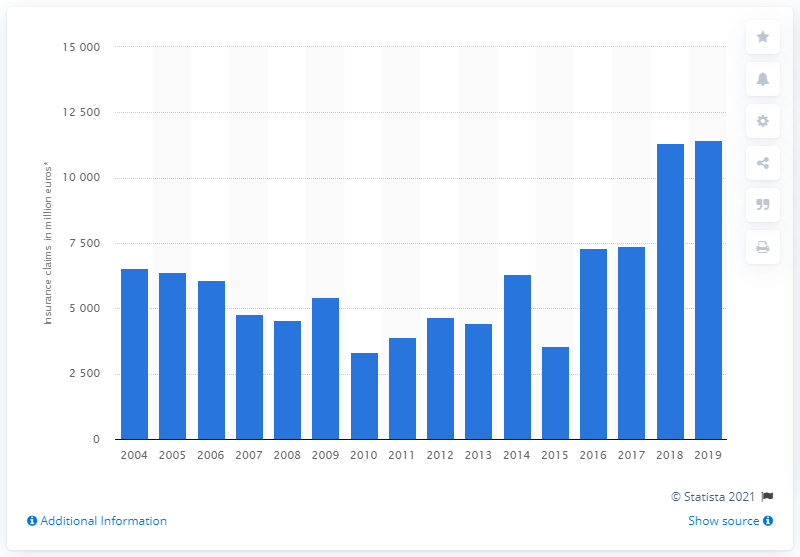Outline some significant characteristics in this image. The number 3314 was the lowest value of claims paid in 2010. 